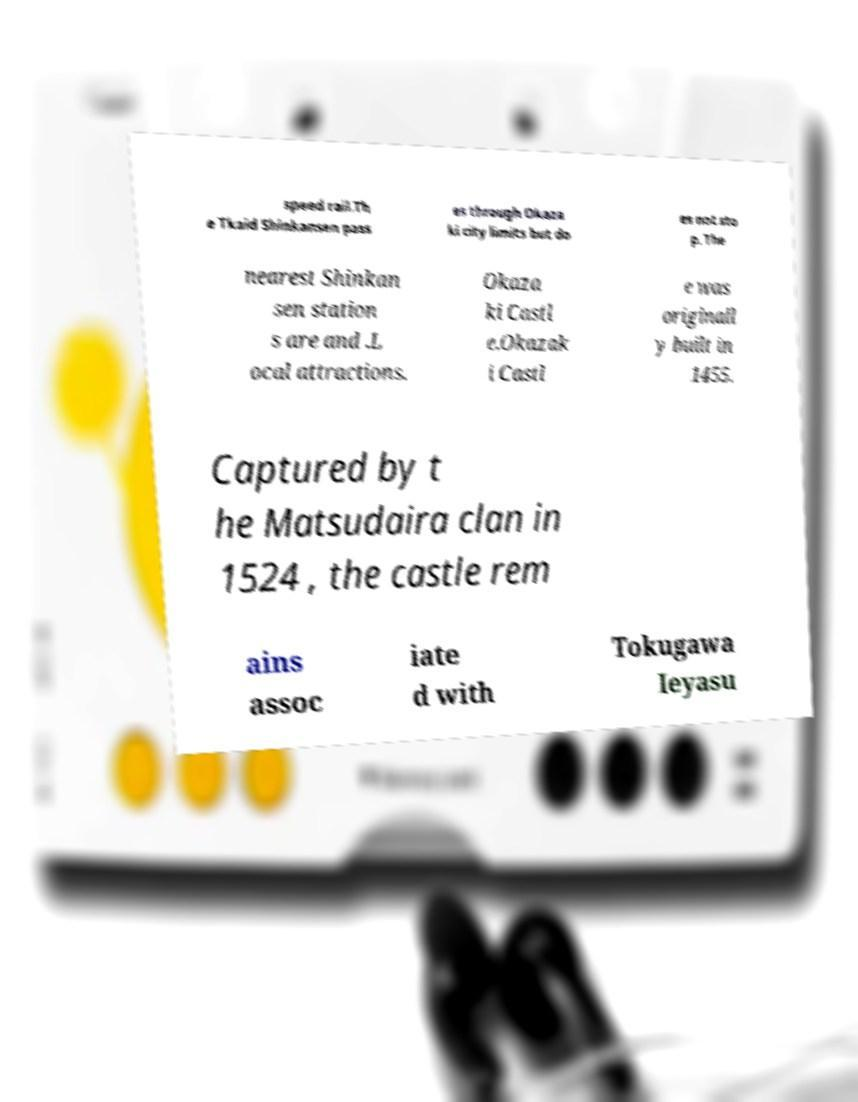I need the written content from this picture converted into text. Can you do that? speed rail.Th e Tkaid Shinkansen pass es through Okaza ki city limits but do es not sto p. The nearest Shinkan sen station s are and .L ocal attractions. Okaza ki Castl e.Okazak i Castl e was originall y built in 1455. Captured by t he Matsudaira clan in 1524 , the castle rem ains assoc iate d with Tokugawa Ieyasu 